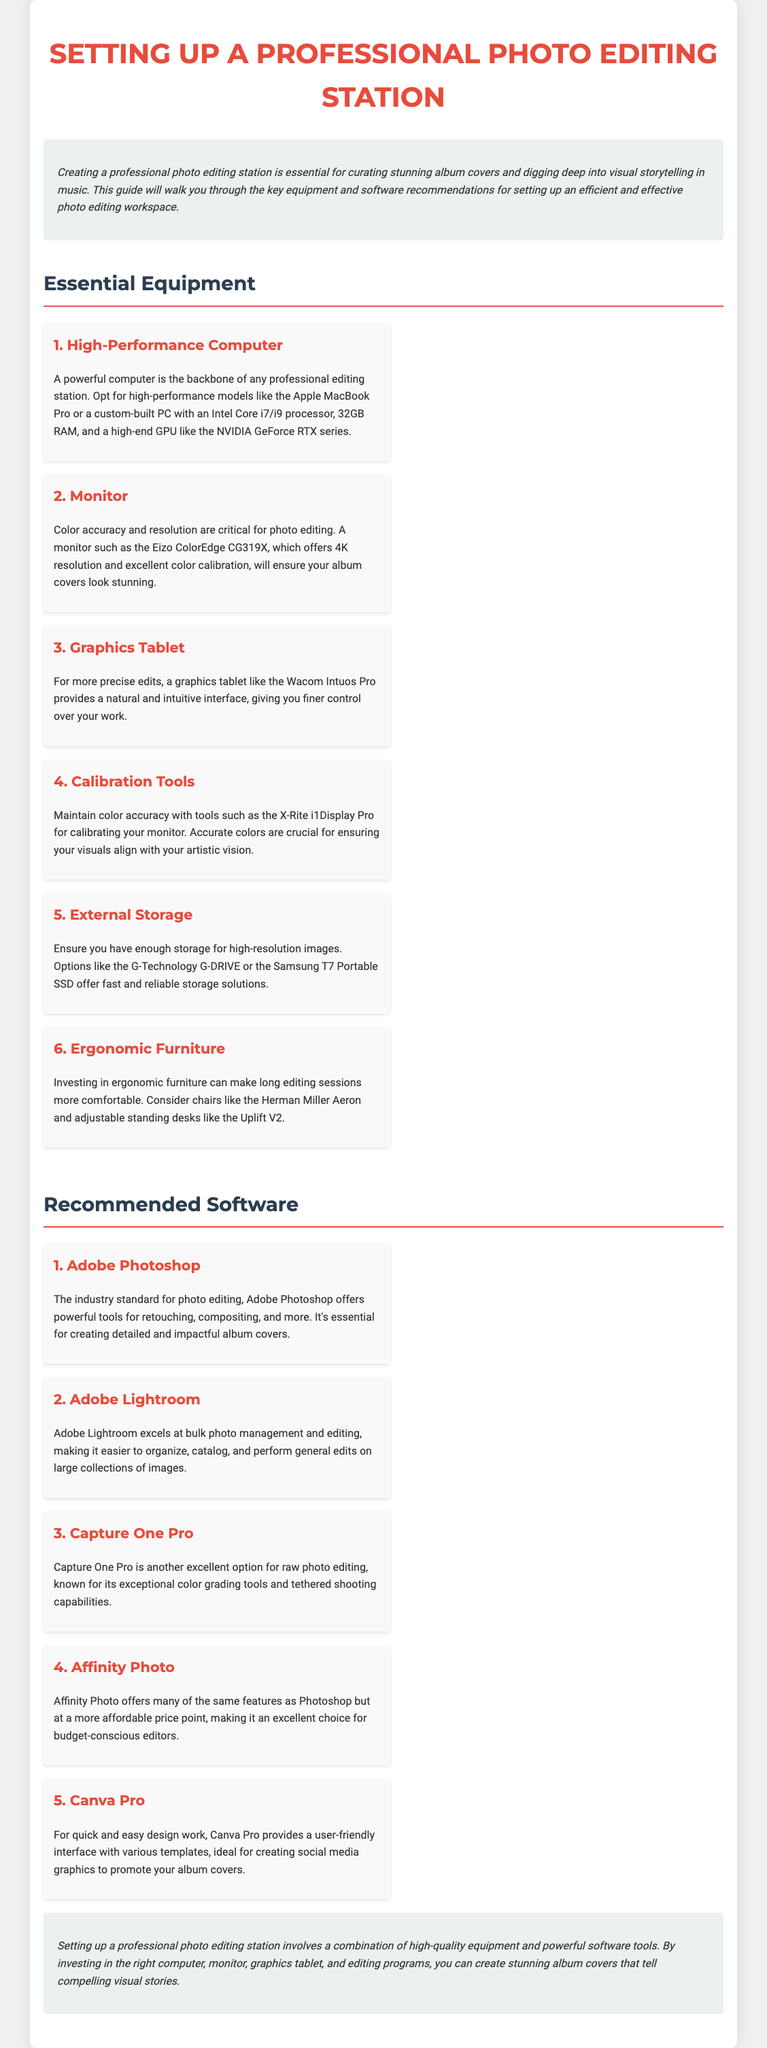what is the first essential equipment listed? The first essential equipment listed is a High-Performance Computer, which is fundamental for a professional editing station.
Answer: High-Performance Computer how many RAM is recommended for the computer? The document recommends 32GB RAM for the high-performance computer to ensure efficient operation.
Answer: 32GB what is the recommended monitor model for color accuracy? The recommended monitor model for color accuracy is the Eizo ColorEdge CG319X, known for its excellent features.
Answer: Eizo ColorEdge CG319X which software is described as the industry standard for photo editing? Adobe Photoshop is described as the industry standard for photo editing, known for its powerful tools.
Answer: Adobe Photoshop what type of tablet is suggested for more precise edits? A graphics tablet, specifically the Wacom Intuos Pro, is suggested to enhance precision in editing tasks.
Answer: Wacom Intuos Pro what is noted as crucial for maintaining color accuracy? Calibration tools, particularly the X-Rite i1Display Pro, are noted as crucial for maintaining color accuracy.
Answer: X-Rite i1Display Pro which editing software is recommended for budget-conscious editors? Affinity Photo is highlighted as a great option for those who are budget-conscious yet need professional features.
Answer: Affinity Photo what furniture type is recommended for comfort during long editing sessions? Ergonomic furniture is recommended to provide comfort during extended editing sessions.
Answer: Ergonomic furniture how many software options are listed under 'Recommended Software'? There are five software options listed under 'Recommended Software' for photo editing.
Answer: five 